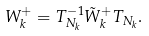Convert formula to latex. <formula><loc_0><loc_0><loc_500><loc_500>W _ { k } ^ { + } = T _ { N _ { k } } ^ { - 1 } \tilde { W } _ { k } ^ { + } T _ { N _ { k } } .</formula> 